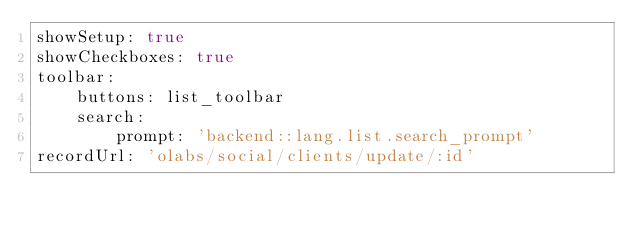<code> <loc_0><loc_0><loc_500><loc_500><_YAML_>showSetup: true
showCheckboxes: true
toolbar:
    buttons: list_toolbar
    search:
        prompt: 'backend::lang.list.search_prompt'
recordUrl: 'olabs/social/clients/update/:id'
</code> 